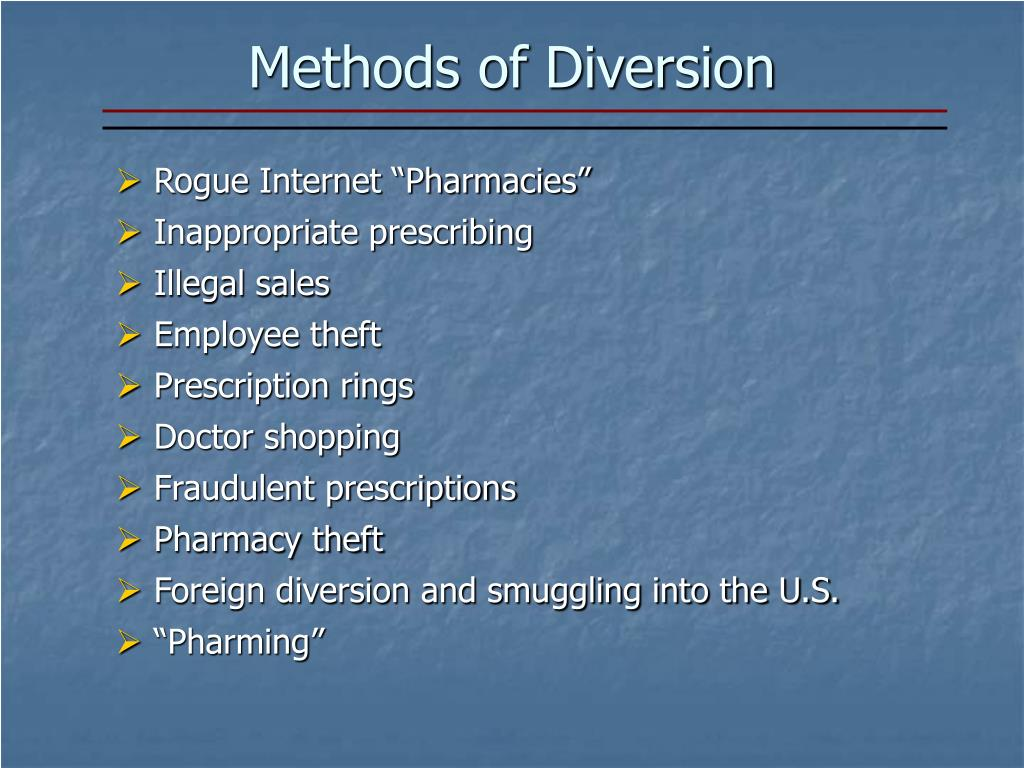Describe a probable scenario where 'Rogue Internet Pharmacies' are involved in the diversion of drugs. A probable scenario involving 'Rogue Internet Pharmacies' could unfold like this: A consumer searching for affordable medications stumbles upon an online pharmacy that offers prescription drugs at unusually low prices. Despite the seemingly professional website, this pharmacy operates outside of legal boundaries. The drugs sold are either counterfeit or diverted from legitimate sources, often originating from countries with lax pharmaceutical regulations. The consumer places an order and receives the medication without a prescription, defying legal protocols. These rogue pharmacies might employ sophisticated marketing strategies through social media and email campaigns, targeting vulnerable populations. This illegal distribution network not only bypasses regulatory oversight but also puts consumers at risk of using unsafe or ineffective medications. 